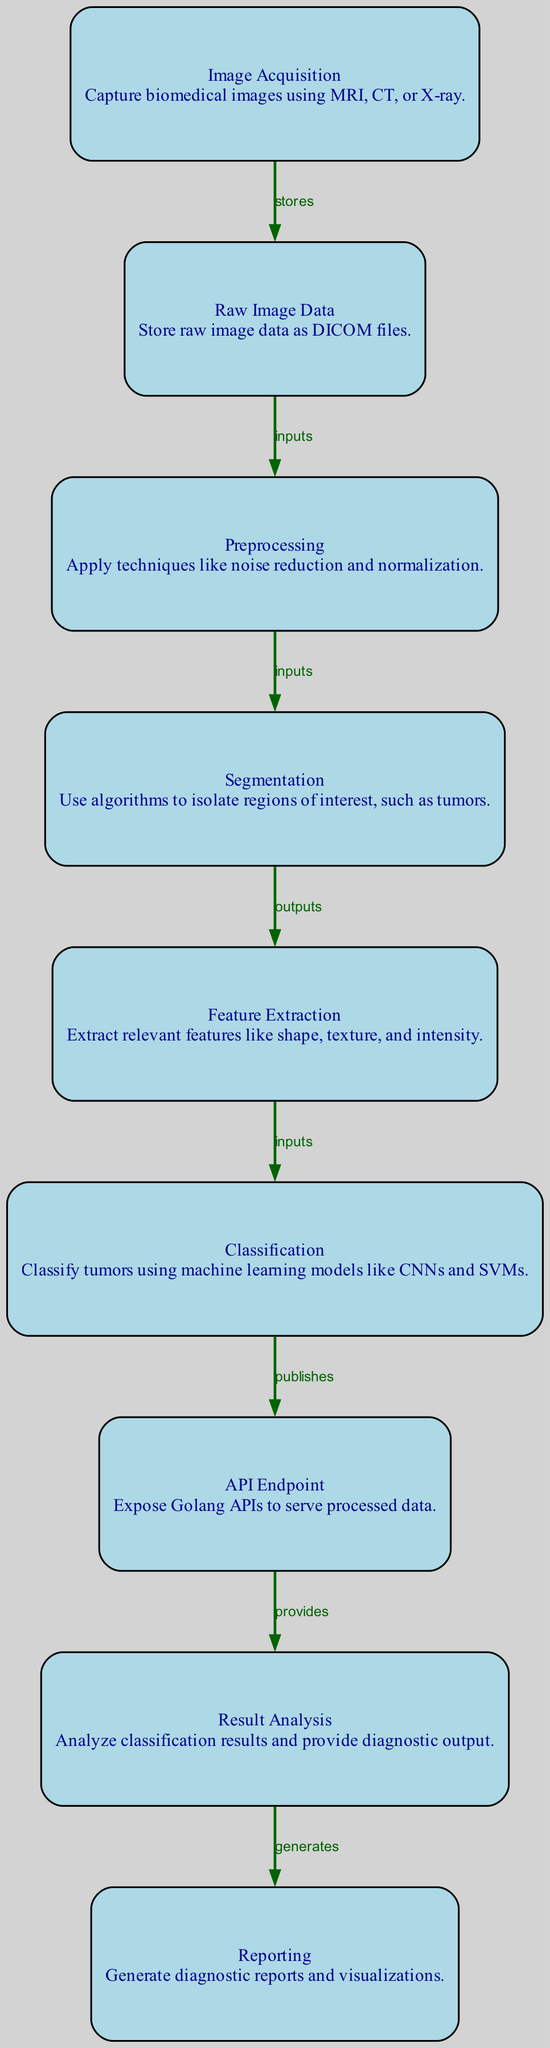What is the first step in the workflow? The first step in the workflow is "Image Acquisition," where biomedical images are captured using techniques like MRI, CT, or X-ray.
Answer: Image Acquisition How many nodes are present in the diagram? By counting the listed nodes, there are a total of nine nodes displayed in the diagram.
Answer: 9 Which node directly follows "Preprocessing"? The node that directly follows "Preprocessing" is "Segmentation," as indicated by the flow of the diagram from one node to the next.
Answer: Segmentation What do we do with the data produced from the "Classification" node? The data produced from the "Classification" node is served through the "API Endpoint," which publishes the processed information to be accessed.
Answer: API Endpoint What type of data is stored in the "Raw Image Data"? The "Raw Image Data" node specifies that it stores data as DICOM files, which are a standard format for medical images.
Answer: DICOM files Which process involves extracting shape, texture, and intensity? The process that involves extracting shape, texture, and intensity is "Feature Extraction," which is a crucial step in analyzing tumor characteristics.
Answer: Feature Extraction What do the "Result Analysis" and "Reporting" nodes produce? The "Result Analysis" node provides a diagnostic output and analyzes classification results, while the "Reporting" node generates diagnostic reports and visualizations, linking these two steps in the workflow.
Answer: Diagnostic output and reports What is the relationship between "Segmentation" and "Feature Extraction"? The relationship is that "Segmentation" outputs its isolated regions of interest, specifically tumors, which are then used as inputs for the next step, "Feature Extraction."
Answer: Outputs and inputs What kind of models are used in the "Classification" process? The "Classification" node mentions the use of machine learning models such as CNNs and SVMs for tumor classification in the workflow.
Answer: CNNs and SVMs 